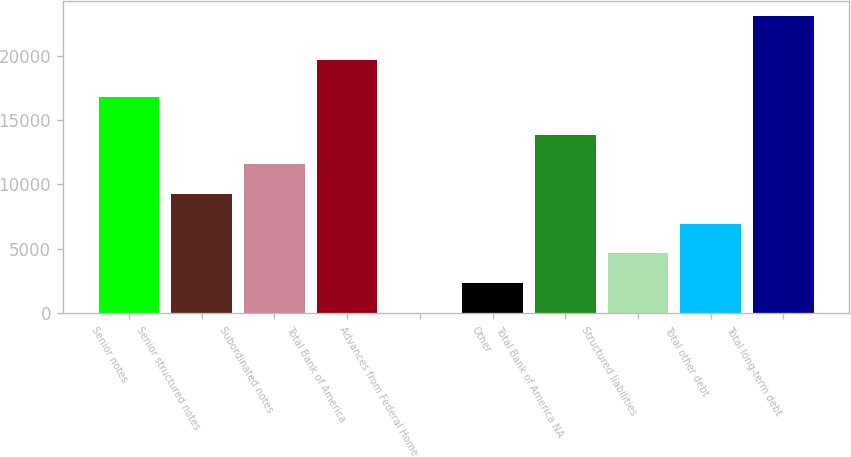<chart> <loc_0><loc_0><loc_500><loc_500><bar_chart><fcel>Senior notes<fcel>Senior structured notes<fcel>Subordinated notes<fcel>Total Bank of America<fcel>Advances from Federal Home<fcel>Other<fcel>Total Bank of America NA<fcel>Structured liabilities<fcel>Total other debt<fcel>Total long-term debt<nl><fcel>16820<fcel>9260.2<fcel>11571.5<fcel>19673<fcel>15<fcel>2326.3<fcel>13882.8<fcel>4637.6<fcel>6948.9<fcel>23128<nl></chart> 